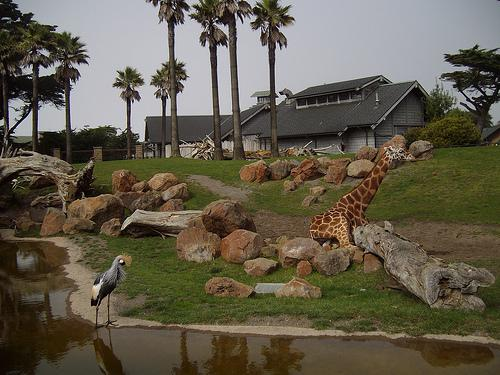Question: what color is the roof?
Choices:
A. Gray.
B. Brown.
C. Tan.
D. Red.
Answer with the letter. Answer: A Question: what is behind the giraffe?
Choices:
A. Trees.
B. Fence.
C. Grassy field.
D. Rocks.
Answer with the letter. Answer: D Question: where was the photo taken?
Choices:
A. Wedding.
B. In a zoo.
C. Church.
D. At home.
Answer with the letter. Answer: B Question: where is the bird?
Choices:
A. Next to the water.
B. In the lake.
C. In the air.
D. In the tree.
Answer with the letter. Answer: A 